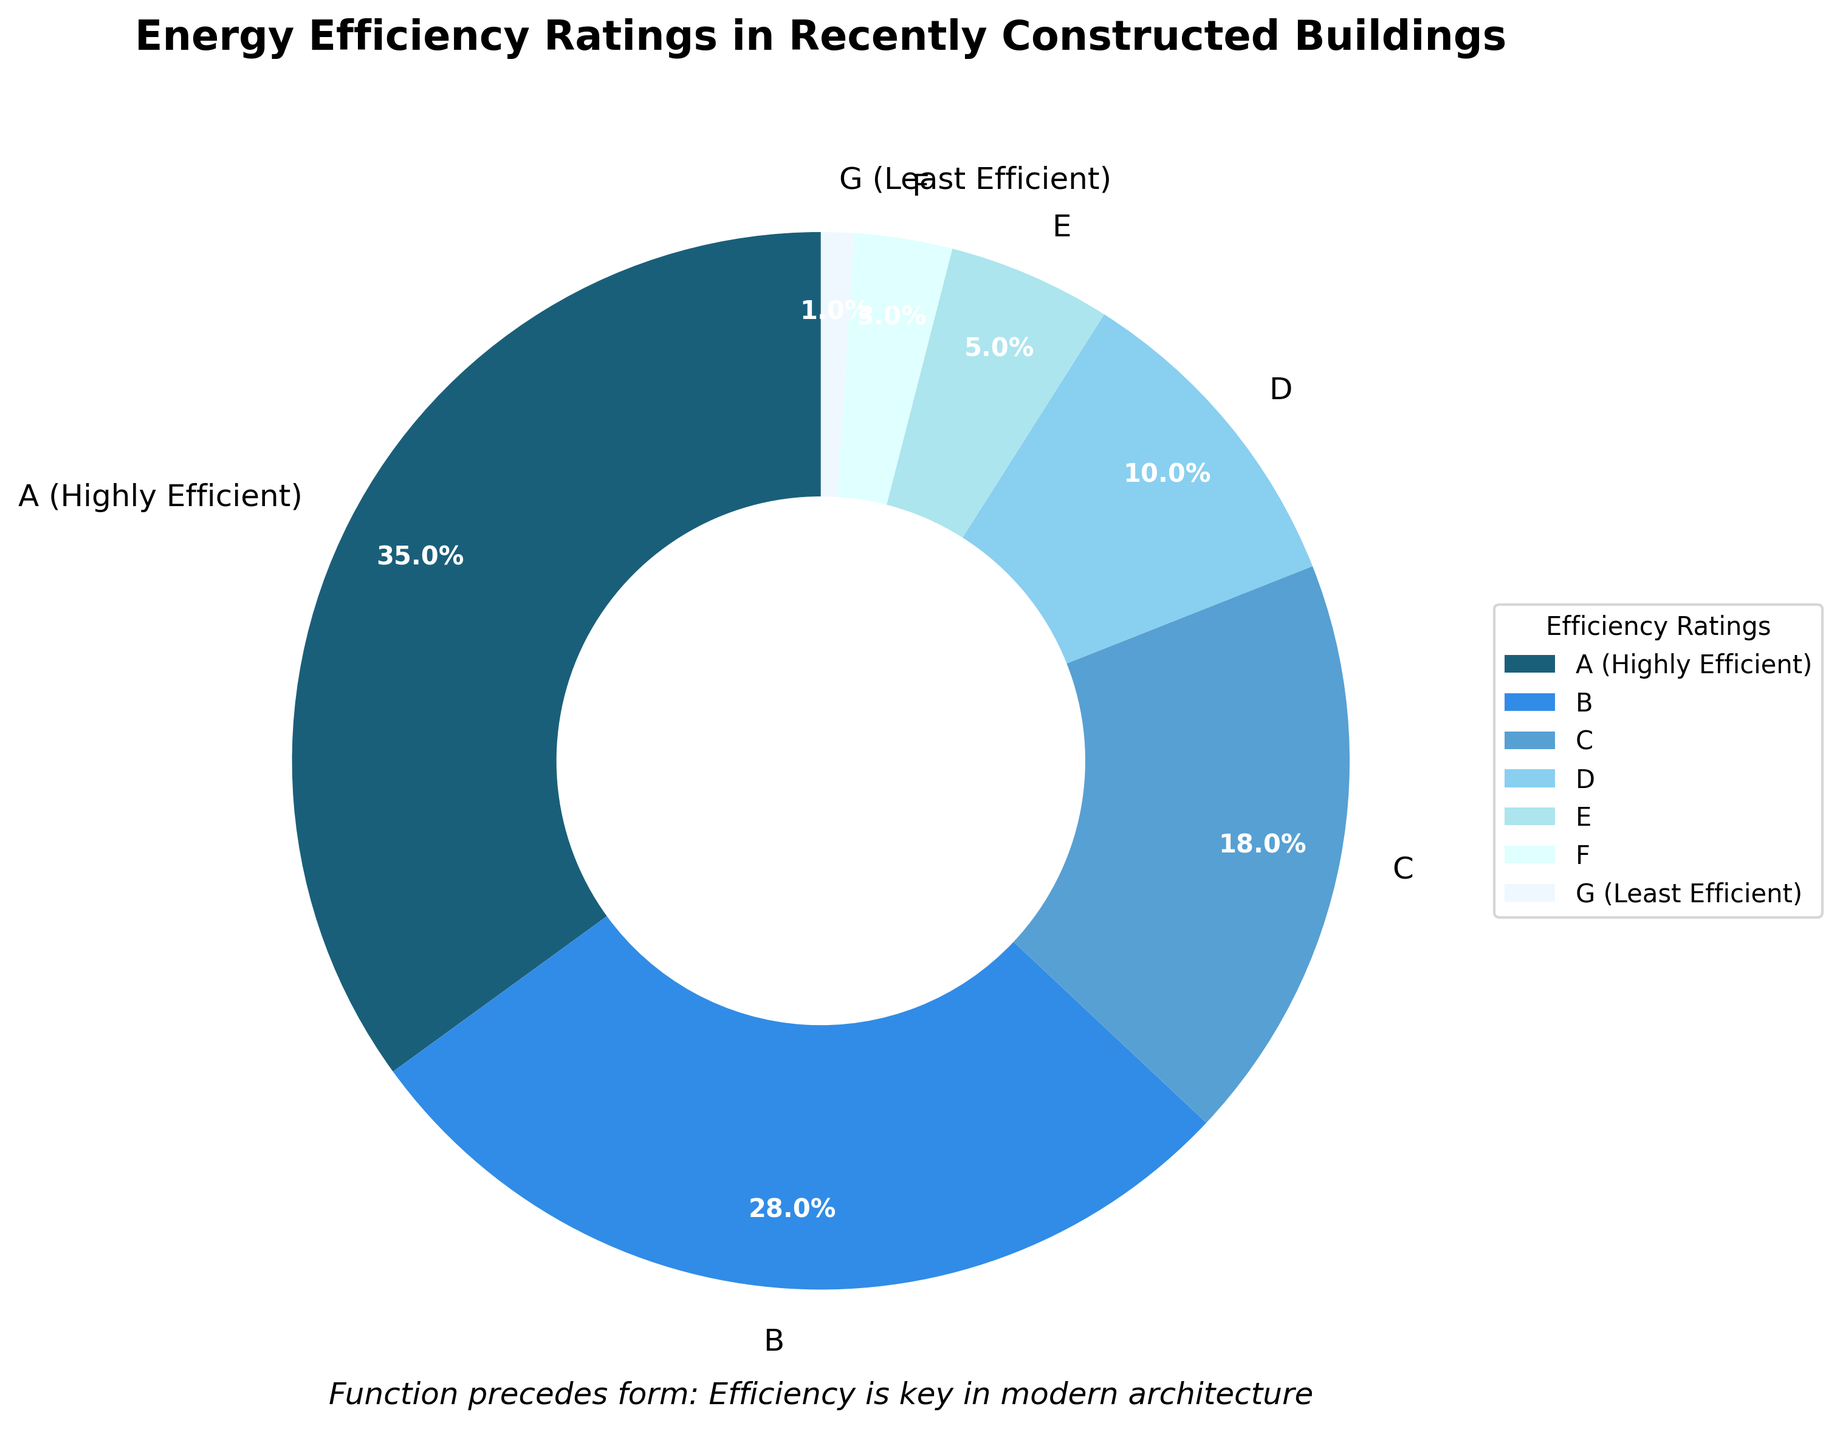What percentage of recently constructed buildings have an energy efficiency rating of 'A (Highly Efficient)'? The figure shows that the 'A (Highly Efficient)' segment in the pie chart corresponds to 35%.
Answer: 35% Which energy efficiency rating has the smallest proportion of buildings? The figure displays each segment's proportion, and the 'G (Least Efficient)' segment is the smallest, indicating 1%.
Answer: G (Least Efficient) What is the combined percentage of buildings with energy efficiency ratings of 'D', 'E', and 'F'? According to the chart, 'D' is 10%, 'E' is 5%, and 'F' is 3%. Adding these percentages together (10% + 5% + 3%), the combined proportion is 18%.
Answer: 18% How do the proportions of buildings with ratings 'A' and 'B' compare? The pie chart shows that 'A (Highly Efficient)' is 35% and 'B' is 28%. So, the rating 'A' has a higher proportion by (35% - 28%) = 7%.
Answer: A has a higher proportion by 7% What is the most popular energy efficiency rating among the recently constructed buildings? The largest slice in the pie chart represents the 'A (Highly Efficient)' rating, which accounts for 35% of the buildings.
Answer: A (Highly Efficient) If a building is not rated as 'C' or below, what are the possible energy efficiency ratings it might have? The ratings 'C' and below include 'C', 'D', 'E', 'F', and 'G'. Therefore, excluding these, the remaining possible ratings are 'A (Highly Efficient)' and 'B'.
Answer: A (Highly Efficient) and B What fraction of the buildings have a rating of 'A' and 'B' combined, expressed as a ratio? The percentages for 'A (Highly Efficient)' and 'B' are 35% and 28%, respectively. Combined, this is 35% + 28% = 63%, which as a fraction is 63/100 or 63:100.
Answer: 63:100 Is the percentage of buildings rated 'C' greater than the cumulative percentage of those rated 'E' and 'F'? The 'C' rating is 18%, and the cumulative percentage of 'E' (5%) and 'F' (3%) is 5% + 3% = 8%. Since 18% is greater than 8%, the 'C' rating has a higher percentage.
Answer: Yes What's the visual cue that articulates the importance of energy efficiency in modern architecture in the chart? The subtitle at the bottom of the chart reads, "Function precedes form: Efficiency is key in modern architecture," emphasizing the importance of energy efficiency visually.
Answer: Subtitle 